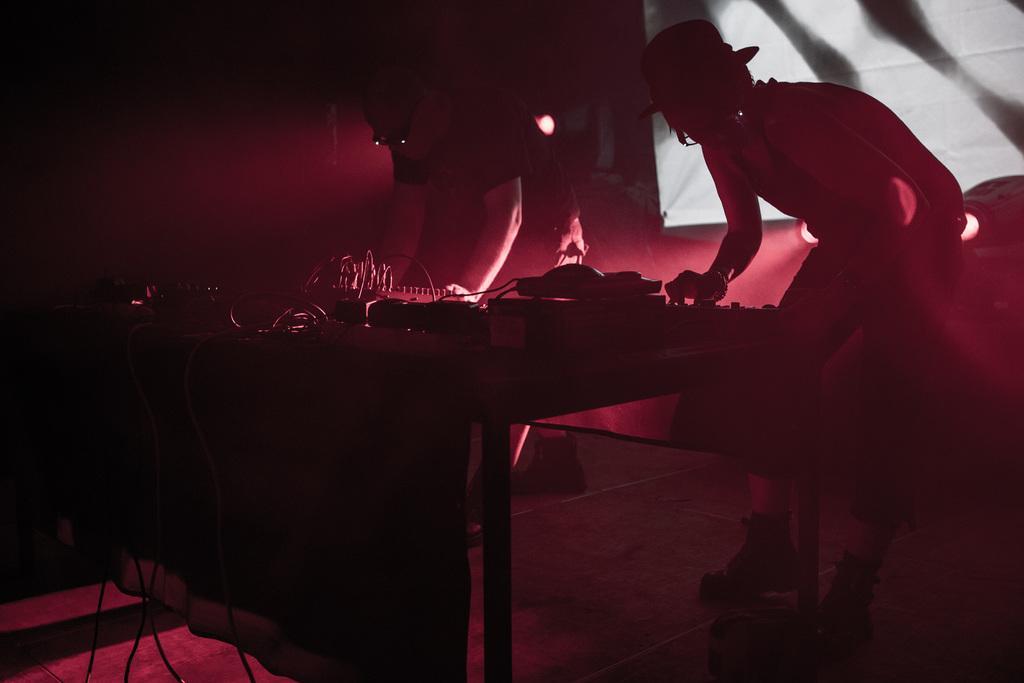How would you summarize this image in a sentence or two? In this picture we can see a few wires and some objects on the table. We can see two people standing. There are lights and other objects. 